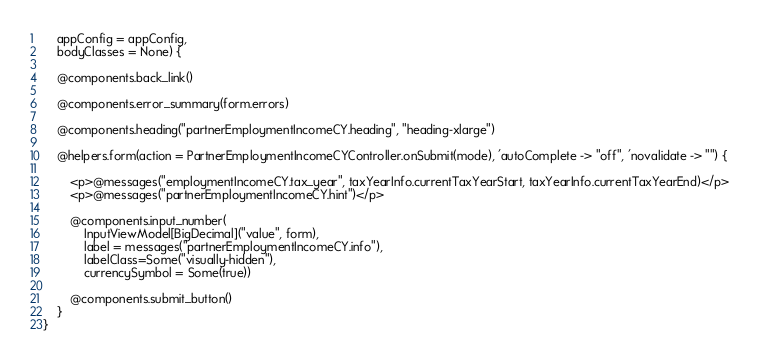<code> <loc_0><loc_0><loc_500><loc_500><_HTML_>    appConfig = appConfig,
    bodyClasses = None) {

    @components.back_link()

    @components.error_summary(form.errors)

    @components.heading("partnerEmploymentIncomeCY.heading", "heading-xlarge")

    @helpers.form(action = PartnerEmploymentIncomeCYController.onSubmit(mode), 'autoComplete -> "off", 'novalidate -> "") {

        <p>@messages("employmentIncomeCY.tax_year", taxYearInfo.currentTaxYearStart, taxYearInfo.currentTaxYearEnd)</p>
        <p>@messages("partnerEmploymentIncomeCY.hint")</p>

        @components.input_number(
            InputViewModel[BigDecimal]("value", form),
            label = messages("partnerEmploymentIncomeCY.info"),
            labelClass=Some("visually-hidden"),
            currencySymbol = Some(true))

        @components.submit_button()
    }
}
</code> 